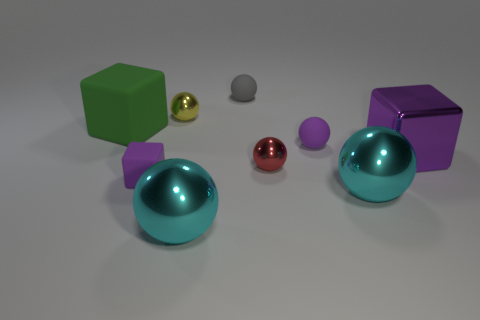Subtract all cyan spheres. How many spheres are left? 4 Subtract all purple spheres. How many spheres are left? 5 Subtract all purple spheres. Subtract all gray cubes. How many spheres are left? 5 Subtract all spheres. How many objects are left? 3 Add 2 red shiny things. How many red shiny things exist? 3 Subtract 0 brown spheres. How many objects are left? 9 Subtract all yellow metal objects. Subtract all big cyan balls. How many objects are left? 6 Add 1 small purple cubes. How many small purple cubes are left? 2 